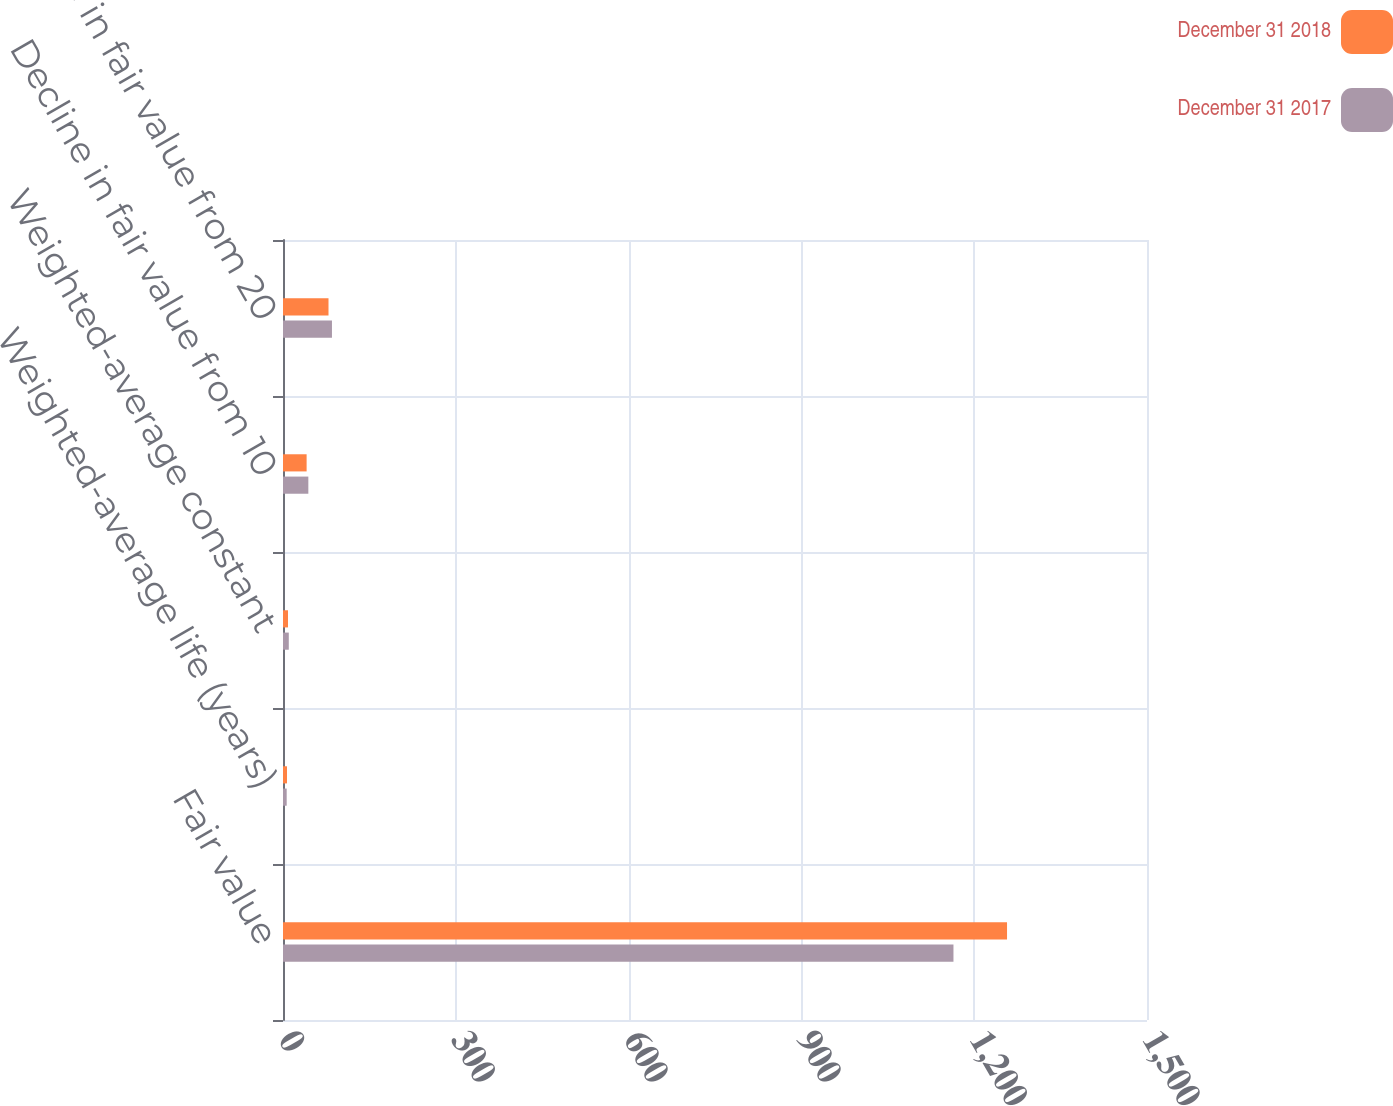Convert chart to OTSL. <chart><loc_0><loc_0><loc_500><loc_500><stacked_bar_chart><ecel><fcel>Fair value<fcel>Weighted-average life (years)<fcel>Weighted-average constant<fcel>Decline in fair value from 10<fcel>Decline in fair value from 20<nl><fcel>December 31 2018<fcel>1257<fcel>6.9<fcel>8.69<fcel>41<fcel>79<nl><fcel>December 31 2017<fcel>1164<fcel>6.4<fcel>10.04<fcel>44<fcel>85<nl></chart> 